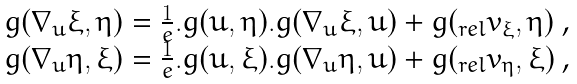<formula> <loc_0><loc_0><loc_500><loc_500>\begin{array} { c } g ( \nabla _ { u } \xi , \eta ) = \frac { 1 } { e } . g ( u , \eta ) . g ( \nabla _ { u } \xi , u ) + g ( _ { r e l } v _ { \xi } , \eta ) \text { ,} \\ g ( \nabla _ { u } \eta , \xi ) = \frac { 1 } { e } . g ( u , \xi ) . g ( \nabla _ { u } \eta , u ) + g ( _ { r e l } v _ { \eta } , \xi ) \text { ,} \end{array}</formula> 